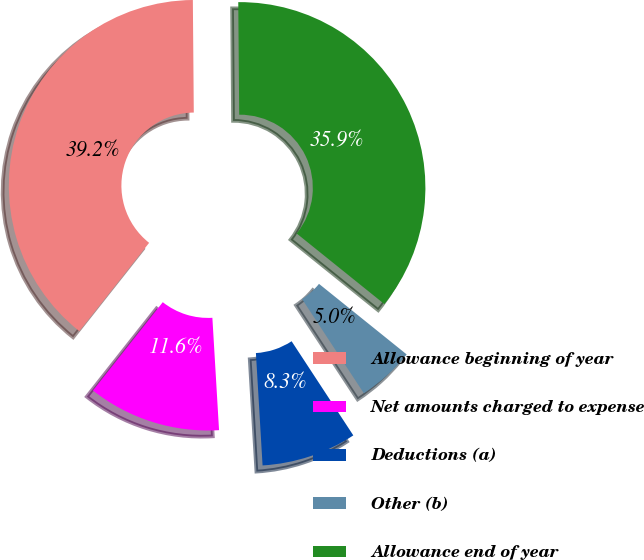Convert chart. <chart><loc_0><loc_0><loc_500><loc_500><pie_chart><fcel>Allowance beginning of year<fcel>Net amounts charged to expense<fcel>Deductions (a)<fcel>Other (b)<fcel>Allowance end of year<nl><fcel>39.22%<fcel>11.59%<fcel>8.29%<fcel>4.98%<fcel>35.92%<nl></chart> 